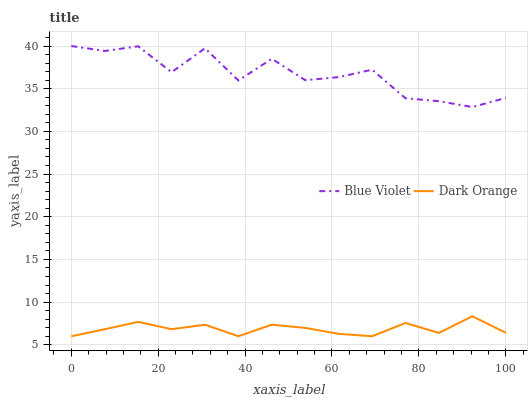Does Blue Violet have the minimum area under the curve?
Answer yes or no. No. Is Blue Violet the smoothest?
Answer yes or no. No. Does Blue Violet have the lowest value?
Answer yes or no. No. Is Dark Orange less than Blue Violet?
Answer yes or no. Yes. Is Blue Violet greater than Dark Orange?
Answer yes or no. Yes. Does Dark Orange intersect Blue Violet?
Answer yes or no. No. 